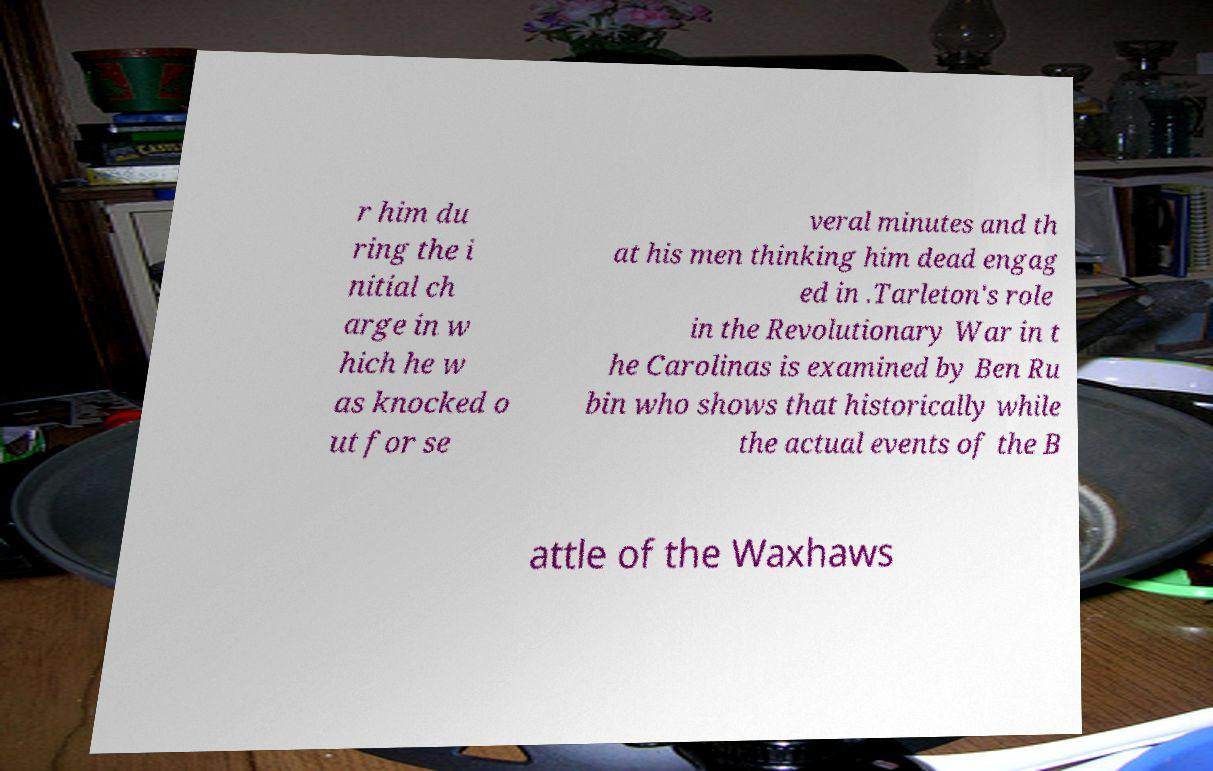What messages or text are displayed in this image? I need them in a readable, typed format. r him du ring the i nitial ch arge in w hich he w as knocked o ut for se veral minutes and th at his men thinking him dead engag ed in .Tarleton's role in the Revolutionary War in t he Carolinas is examined by Ben Ru bin who shows that historically while the actual events of the B attle of the Waxhaws 